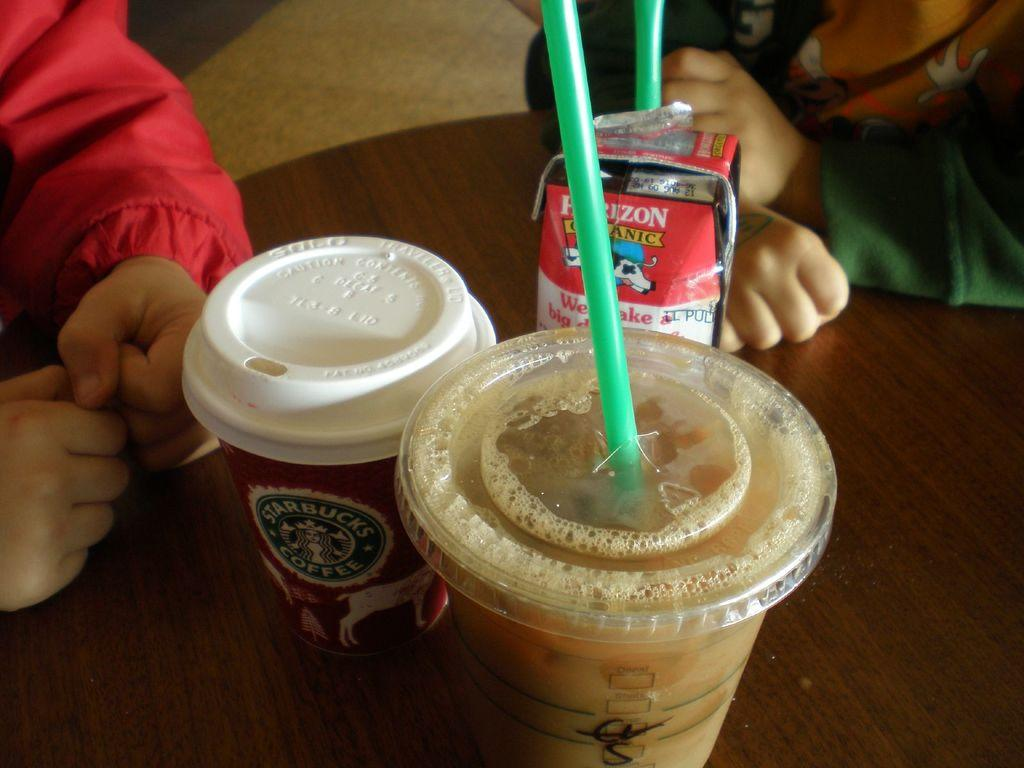What type of objects are present in the image that humans might use? There is a glass and another glass with a straw in the image. What else is present on the table in the image? There is a sachet with a straw on the table in the image. Can you describe the humans in the image? The facts provided do not give specific details about the humans in the image. What type of berry is being cooked on the stove in the image? There is no stove or berry present in the image. 